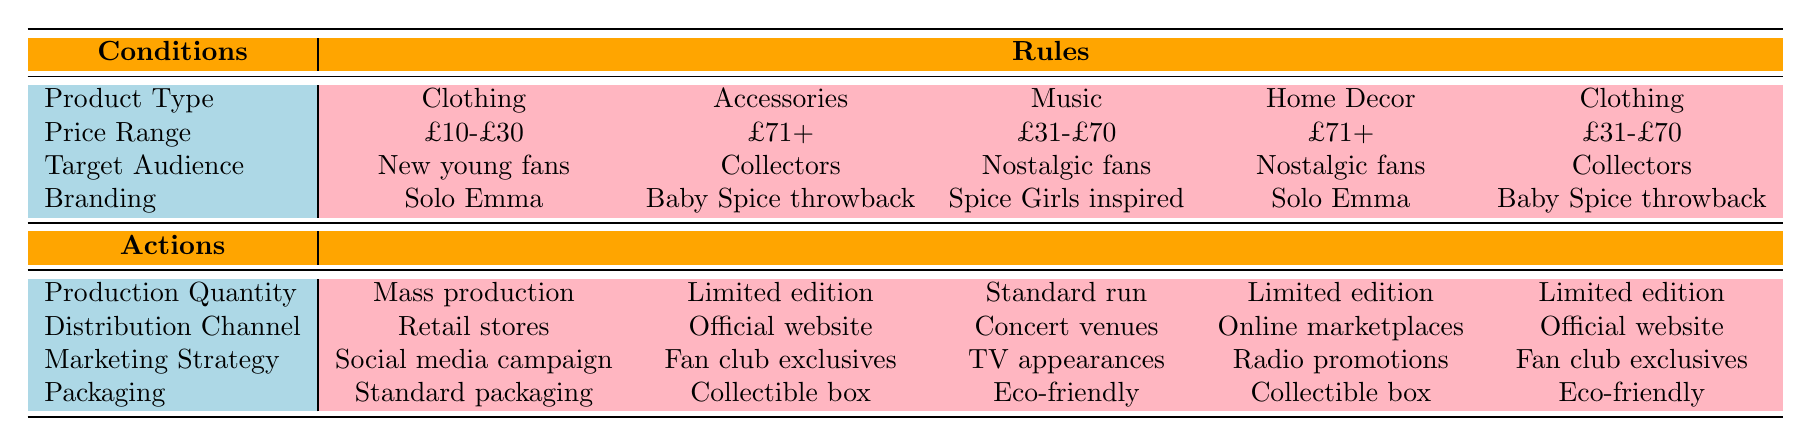What type of merchandise is aimed at new young fans within a budget-friendly price range? Looking at the conditions, the only entry that matches "Clothing," "Budget-friendly (£10-£30)," and "New young fans" leads to the conclusion that these items are produced with a marketing strategy of "Social media campaign" and have "Standard packaging."
Answer: Clothing Which branding strategy is associated with limited edition accessories targeted at collectors? Observing the specific rule for accessories that are premium priced (£71+), aimed at collectors, and branded as "Baby Spice throwback," indicates that this combination yields actions of "Limited edition," "Official website," "Fan club exclusives," and "Collectible box."
Answer: Baby Spice throwback Is there any home decor merchandise in a premium price range aimed at nostalgic fans produced for an online marketplace? The rule associated with "Home Decor," "Premium (£71+)," "Nostalgic fans," and "Solo Emma" indicates this combination results in "Limited edition," with "Online marketplaces" listed for distribution. Therefore, the answer is yes.
Answer: Yes What is the production quantity of clothing targeted at collectors and priced in the mid-range? The table specifies clothing in the mid-range (£31-£70) aimed at collectors with the branding of "Baby Spice throwback," resulting in a production quantity described as "Limited edition."
Answer: Limited edition How many different distribution channels are associated with clothing products aimed at new young fans? The identified merchandise aimed at new young fans under conditions of "Clothing," "Budget-friendly (£10-£30)" leads to the action of utilizing only one distribution channel, which is "Retail stores."
Answer: 1 